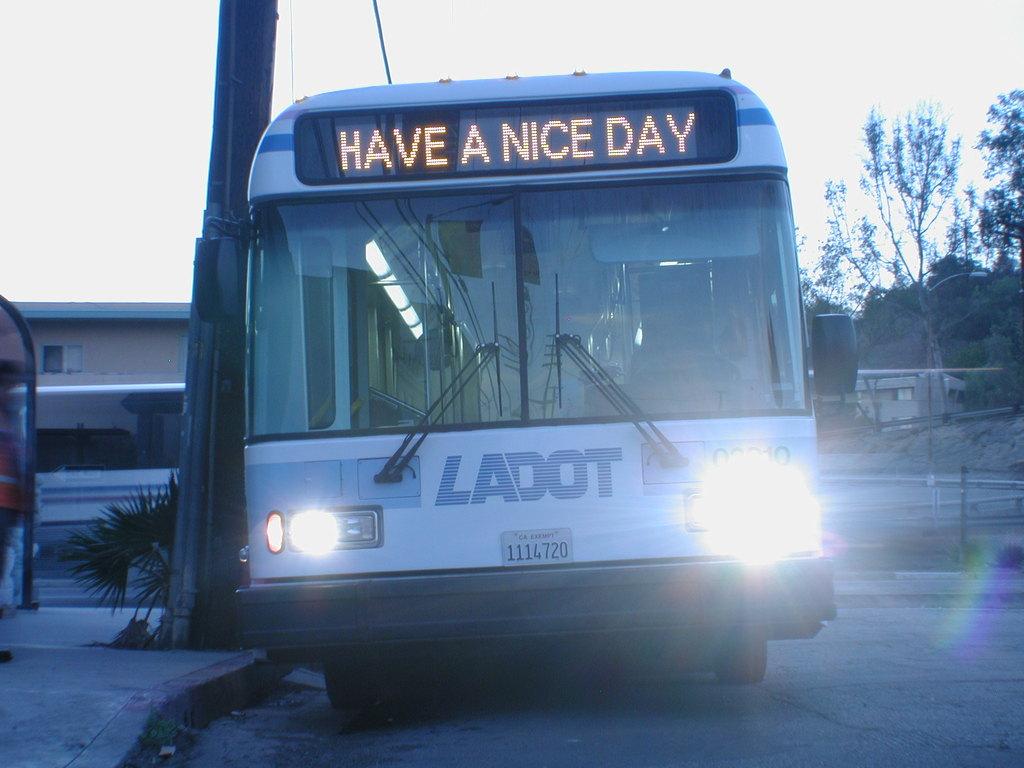What does the bus say on its text display?
Offer a terse response. Have a nice day. What is the brand of the bus?
Give a very brief answer. Ladot. 